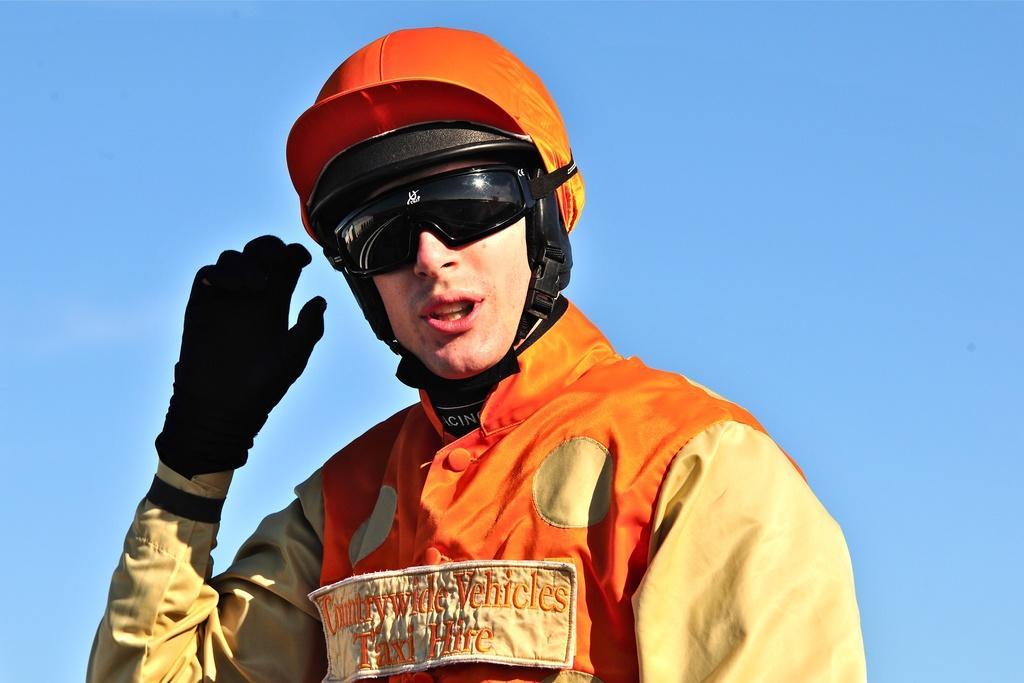What is the main subject of the image? The main subject of the image is a man. Can you describe the man's attire in the image? The man is wearing a cap, sunglasses, a glove on his hand, and a jacket in the image. What is the color of the sky in the image? The sky is blue in the image. What type of meal is the man preparing in the image? There is no indication in the image that the man is preparing a meal, as he is not shown holding any food or cooking utensils. Can you tell me how many feathers are on the man's jacket in the image? There is no mention of feathers on the man's jacket in the provided facts, so it cannot be determined from the image. 